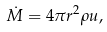<formula> <loc_0><loc_0><loc_500><loc_500>\dot { M } = 4 \pi r ^ { 2 } \rho u ,</formula> 